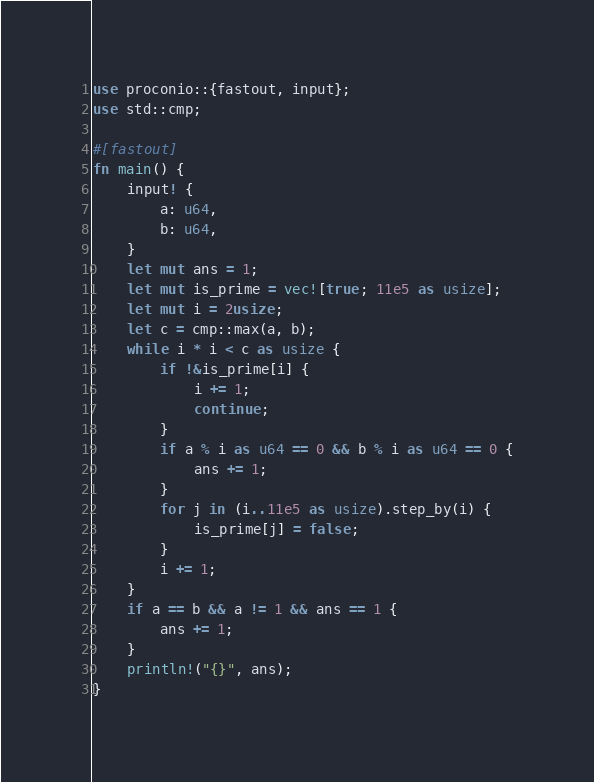Convert code to text. <code><loc_0><loc_0><loc_500><loc_500><_Rust_>use proconio::{fastout, input};
use std::cmp;

#[fastout]
fn main() {
    input! {
        a: u64,
        b: u64,
    }
    let mut ans = 1;
    let mut is_prime = vec![true; 11e5 as usize];
    let mut i = 2usize;
    let c = cmp::max(a, b);
    while i * i < c as usize {
        if !&is_prime[i] {
            i += 1;
            continue;
        }
        if a % i as u64 == 0 && b % i as u64 == 0 {
            ans += 1;
        }
        for j in (i..11e5 as usize).step_by(i) {
            is_prime[j] = false;
        }
        i += 1;
    }
    if a == b && a != 1 && ans == 1 {
        ans += 1;
    }
    println!("{}", ans);
}
</code> 